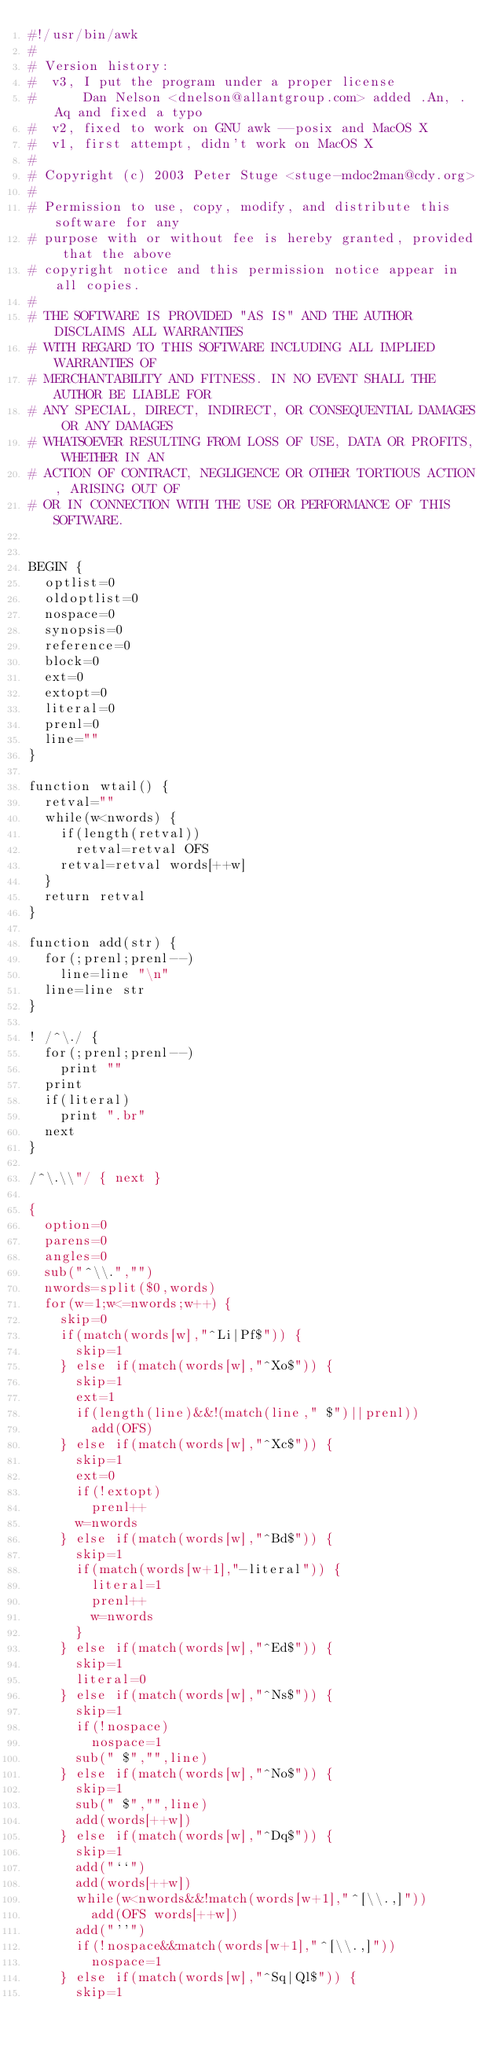Convert code to text. <code><loc_0><loc_0><loc_500><loc_500><_Awk_>#!/usr/bin/awk
#
# Version history:
#  v3, I put the program under a proper license
#      Dan Nelson <dnelson@allantgroup.com> added .An, .Aq and fixed a typo
#  v2, fixed to work on GNU awk --posix and MacOS X
#  v1, first attempt, didn't work on MacOS X
#
# Copyright (c) 2003 Peter Stuge <stuge-mdoc2man@cdy.org>
#
# Permission to use, copy, modify, and distribute this software for any
# purpose with or without fee is hereby granted, provided that the above
# copyright notice and this permission notice appear in all copies.
#
# THE SOFTWARE IS PROVIDED "AS IS" AND THE AUTHOR DISCLAIMS ALL WARRANTIES
# WITH REGARD TO THIS SOFTWARE INCLUDING ALL IMPLIED WARRANTIES OF
# MERCHANTABILITY AND FITNESS. IN NO EVENT SHALL THE AUTHOR BE LIABLE FOR
# ANY SPECIAL, DIRECT, INDIRECT, OR CONSEQUENTIAL DAMAGES OR ANY DAMAGES
# WHATSOEVER RESULTING FROM LOSS OF USE, DATA OR PROFITS, WHETHER IN AN
# ACTION OF CONTRACT, NEGLIGENCE OR OTHER TORTIOUS ACTION, ARISING OUT OF
# OR IN CONNECTION WITH THE USE OR PERFORMANCE OF THIS SOFTWARE.


BEGIN {
  optlist=0
  oldoptlist=0
  nospace=0
  synopsis=0
  reference=0
  block=0
  ext=0
  extopt=0
  literal=0
  prenl=0
  line=""
}

function wtail() {
  retval=""
  while(w<nwords) {
    if(length(retval))
      retval=retval OFS
    retval=retval words[++w]
  }
  return retval
}

function add(str) {
  for(;prenl;prenl--)
    line=line "\n"
  line=line str
}

! /^\./ {
  for(;prenl;prenl--)
    print ""
  print
  if(literal)
    print ".br"
  next
}

/^\.\\"/ { next }

{
  option=0
  parens=0
  angles=0
  sub("^\\.","")
  nwords=split($0,words)
  for(w=1;w<=nwords;w++) {
    skip=0
    if(match(words[w],"^Li|Pf$")) {
      skip=1
    } else if(match(words[w],"^Xo$")) {
      skip=1
      ext=1
      if(length(line)&&!(match(line," $")||prenl))
        add(OFS)
    } else if(match(words[w],"^Xc$")) {
      skip=1
      ext=0
      if(!extopt)
        prenl++
      w=nwords
    } else if(match(words[w],"^Bd$")) {
      skip=1
      if(match(words[w+1],"-literal")) {
        literal=1
        prenl++
        w=nwords
      }
    } else if(match(words[w],"^Ed$")) {
      skip=1
      literal=0
    } else if(match(words[w],"^Ns$")) {
      skip=1
      if(!nospace)
        nospace=1
      sub(" $","",line)
    } else if(match(words[w],"^No$")) {
      skip=1
      sub(" $","",line)
      add(words[++w])
    } else if(match(words[w],"^Dq$")) {
      skip=1
      add("``")
      add(words[++w])
      while(w<nwords&&!match(words[w+1],"^[\\.,]"))
        add(OFS words[++w])
      add("''")
      if(!nospace&&match(words[w+1],"^[\\.,]"))
        nospace=1
    } else if(match(words[w],"^Sq|Ql$")) {
      skip=1</code> 